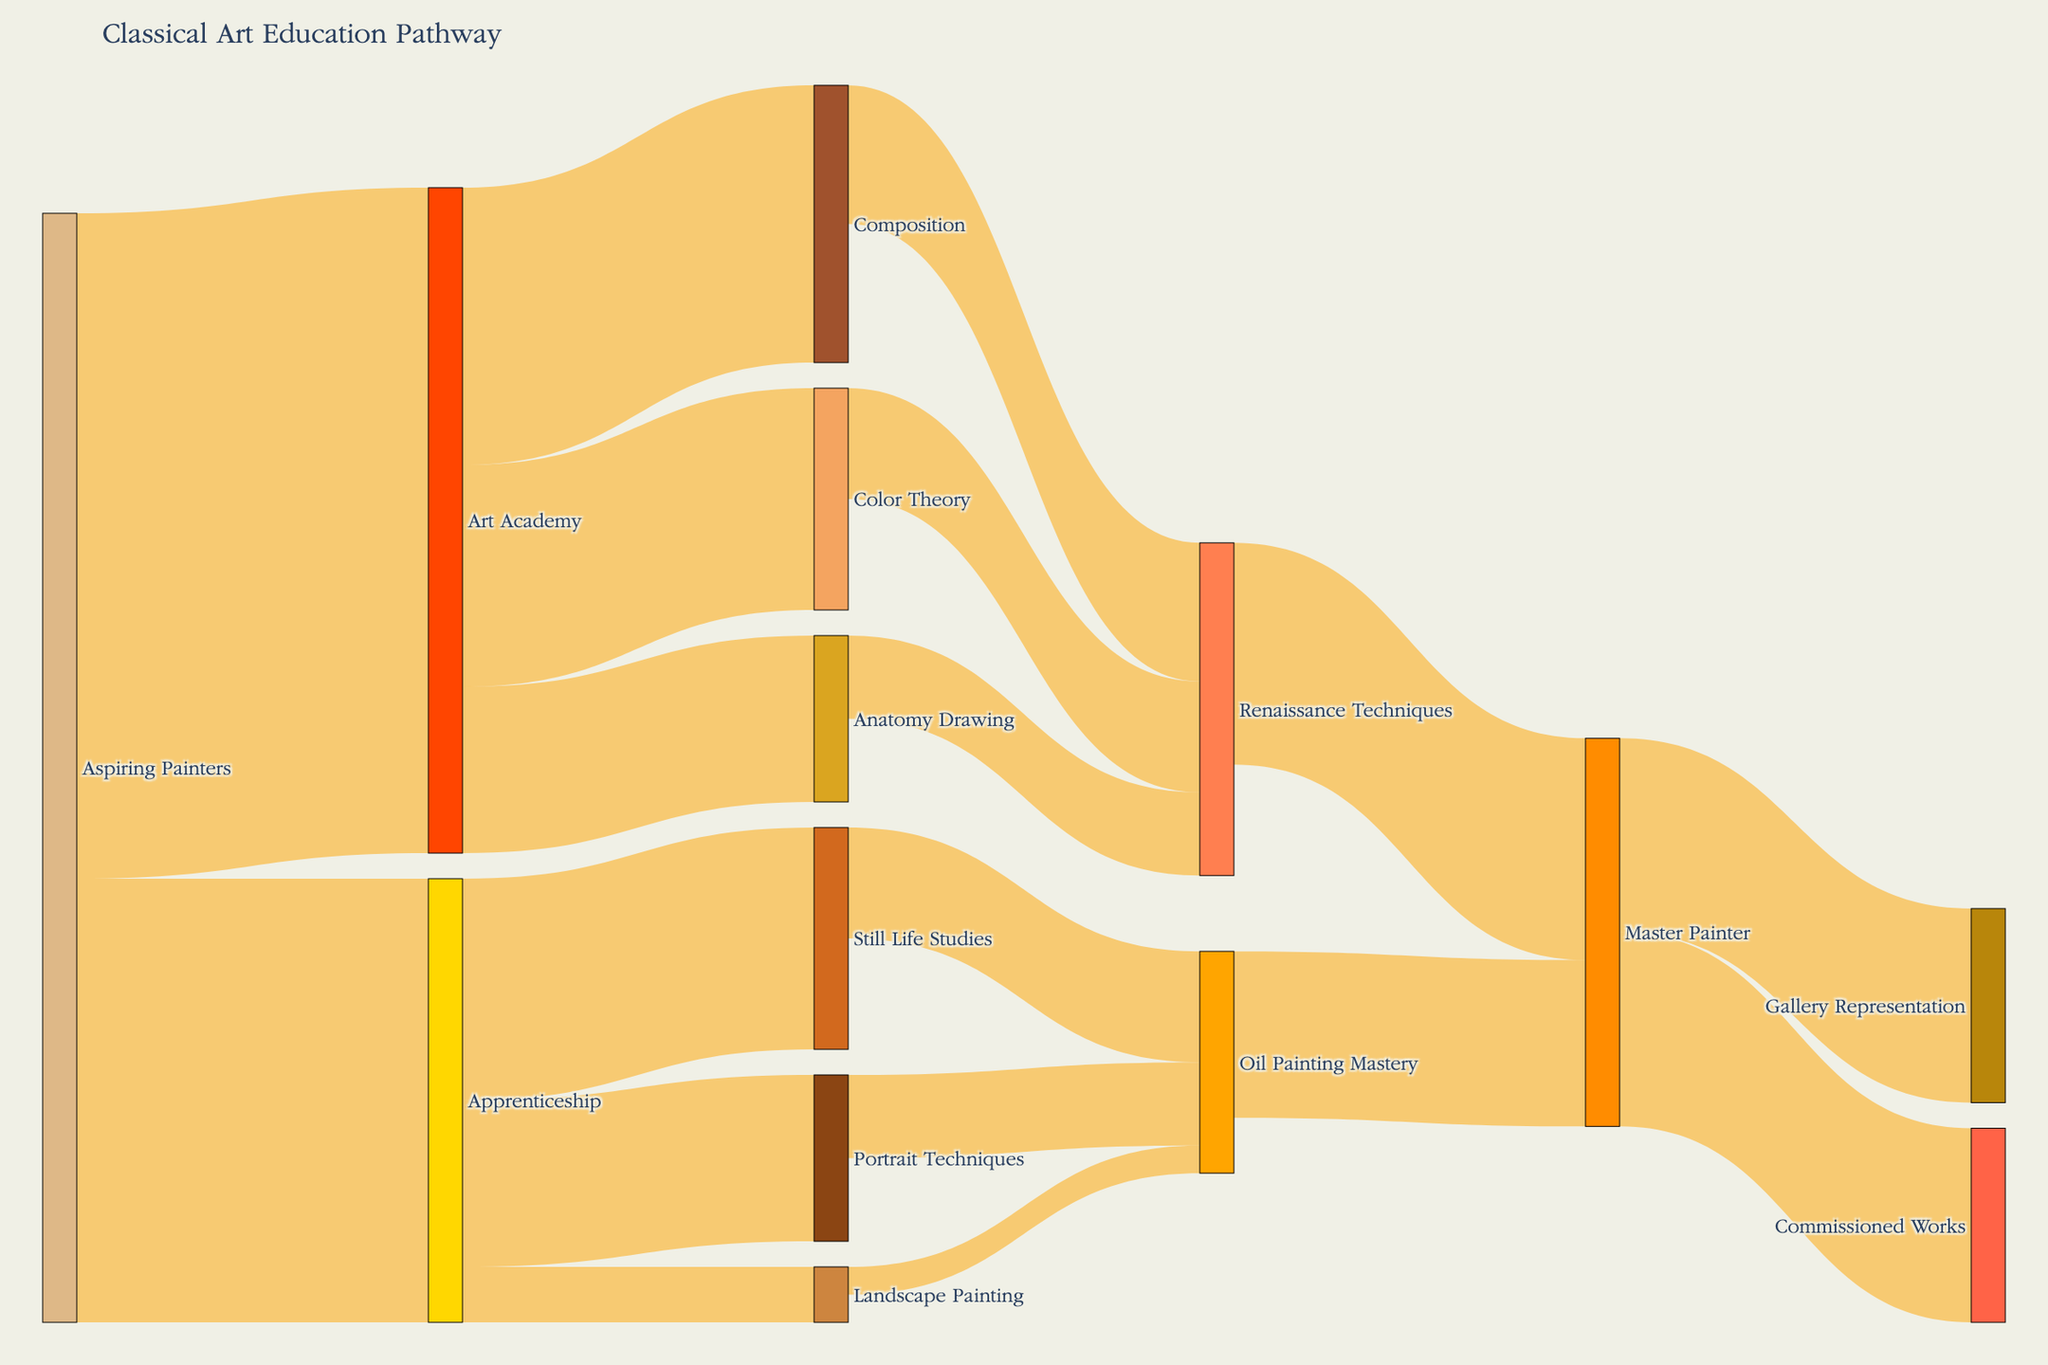Which pathway has more aspiring painters, Apprenticeship or Art Academy? The figure shows that 400 aspiring painters choose Apprenticeship and 600 choose Art Academy.
Answer: Art Academy How many aspiring painters end up studying Color Theory at Art Academy? The figure indicates that 200 aspiring painters from the Art Academy study Color Theory.
Answer: 200 What is the final step for aspiring painters who master Oil Painting? The figure illustrates that aspiring painters who master Oil Painting eventually become Master Painters.
Answer: Master Painters Are there more Master Painters from Oil Painting Mastery or Renaissance Techniques? The figure shows that 150 Master Painters come from Oil Painting Mastery, while 200 come from Renaissance Techniques.
Answer: Renaissance Techniques How many pathways lead to painting mastery? The figure showcases multiple pathways that converge into two major final stages leading to mastery: Oil Painting Mastery and Renaissance Techniques.
Answer: 2 How many students end up being represented in galleries after becoming Master Painters? The figure explains that 175 students who become Master Painters go on to achieve Gallery Representation.
Answer: 175 What is the combined number of students who pursue Still Life Studies, Portrait Techniques, and Landscape Painting after Apprenticeship? The figure shows 200 students in Still Life Studies, 150 in Portrait Techniques, and 50 in Landscape Painting. Summing these values gives 200 + 150 + 50 = 400.
Answer: 400 Which educational step from Art Academy has the most students? The figure reveals that Composition has 250 students, Color Theory has 200, and Anatomy Drawing has 150. Composition has the most students.
Answer: Composition What is the final destination for an aspiring painter who goes through both Color Theory and Renaissance Techniques? The figure indicates that after Color Theory, students head to Renaissance Techniques and those later become Master Painters.
Answer: Master Painters Compare the number of Master Painters who pursue Gallery Representation versus those who take on Commissioned Works. The figure shows that 175 Master Painters are represented in galleries, and 175 handle commissioned works, making these two paths equal in number.
Answer: Equal 